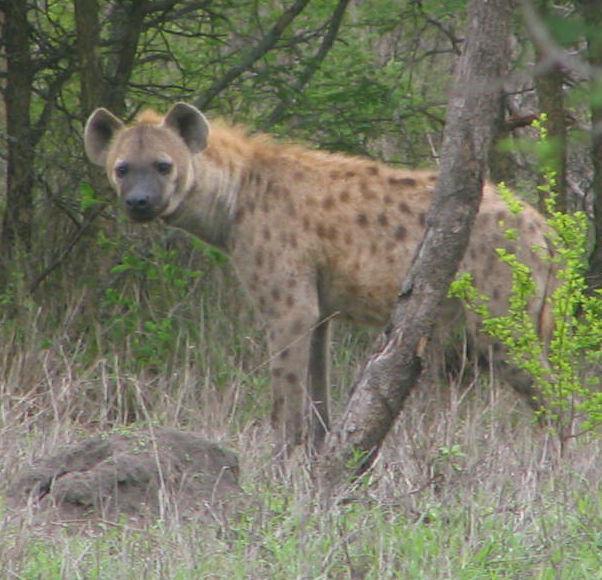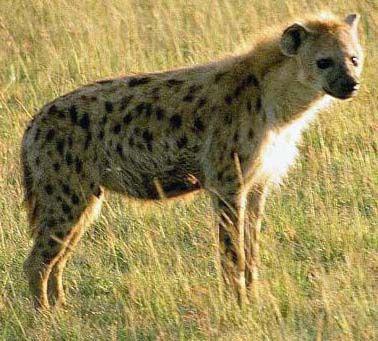The first image is the image on the left, the second image is the image on the right. For the images displayed, is the sentence "The left image shows one hyena on all fours with its head lowered and to the right." factually correct? Answer yes or no. No. The first image is the image on the left, the second image is the image on the right. Assess this claim about the two images: "More animals are in the image on the right.". Correct or not? Answer yes or no. No. 